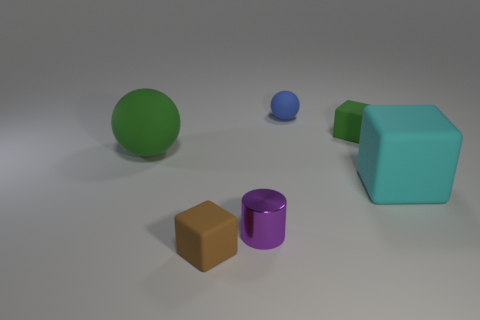There is a brown object that is the same size as the purple cylinder; what is its material?
Offer a terse response. Rubber. Is there another metallic sphere that has the same size as the green ball?
Provide a succinct answer. No. What is the size of the green rubber object that is on the left side of the green rubber block?
Your answer should be compact. Large. How big is the cyan rubber cube?
Provide a succinct answer. Large. What number of cylinders are small blue rubber things or small objects?
Provide a short and direct response. 1. The green cube that is the same material as the small brown object is what size?
Keep it short and to the point. Small. How many blocks have the same color as the large matte sphere?
Your answer should be very brief. 1. Are there any blue rubber spheres on the right side of the blue object?
Make the answer very short. No. There is a brown matte thing; does it have the same shape as the big thing behind the cyan thing?
Your response must be concise. No. How many things are rubber cubes that are right of the purple thing or green matte balls?
Ensure brevity in your answer.  3. 